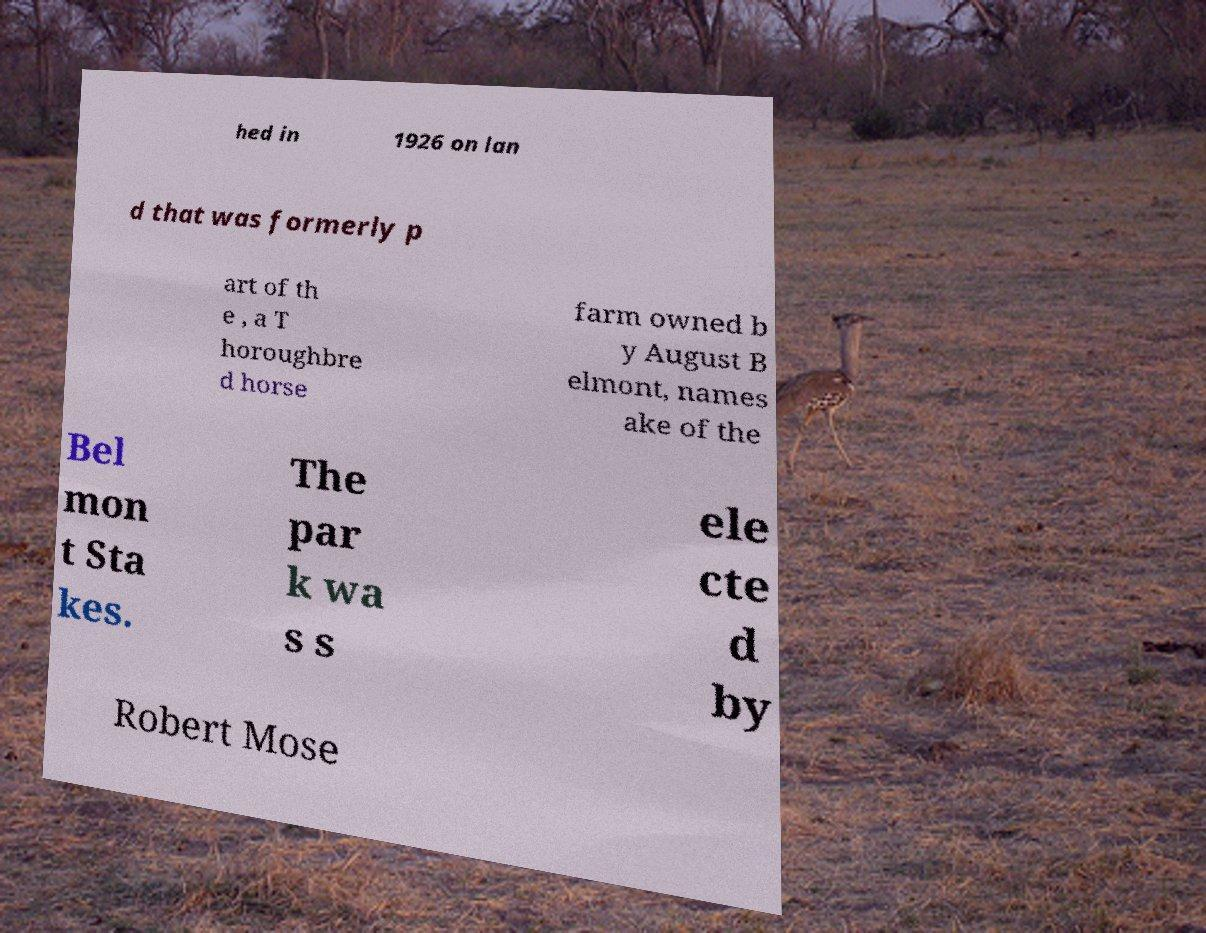For documentation purposes, I need the text within this image transcribed. Could you provide that? hed in 1926 on lan d that was formerly p art of th e , a T horoughbre d horse farm owned b y August B elmont, names ake of the Bel mon t Sta kes. The par k wa s s ele cte d by Robert Mose 